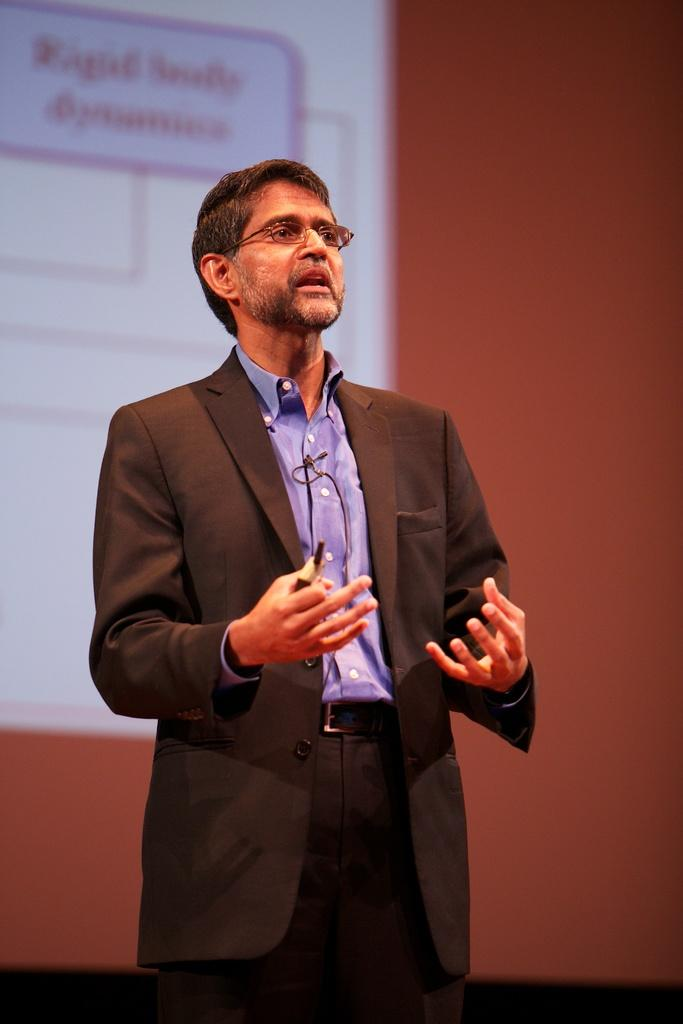What is the main subject of the image? There is a person standing in the image. What is the person holding in their hand? The person is holding an object in their hand. What can be seen on the wall in the background of the image? There is a screen on the wall in the background of the image. How many ducks are visible in the image? There are no ducks present in the image. What type of crowd can be seen gathering around the person in the image? There is no crowd present in the image; it only shows a person standing and holding an object. 